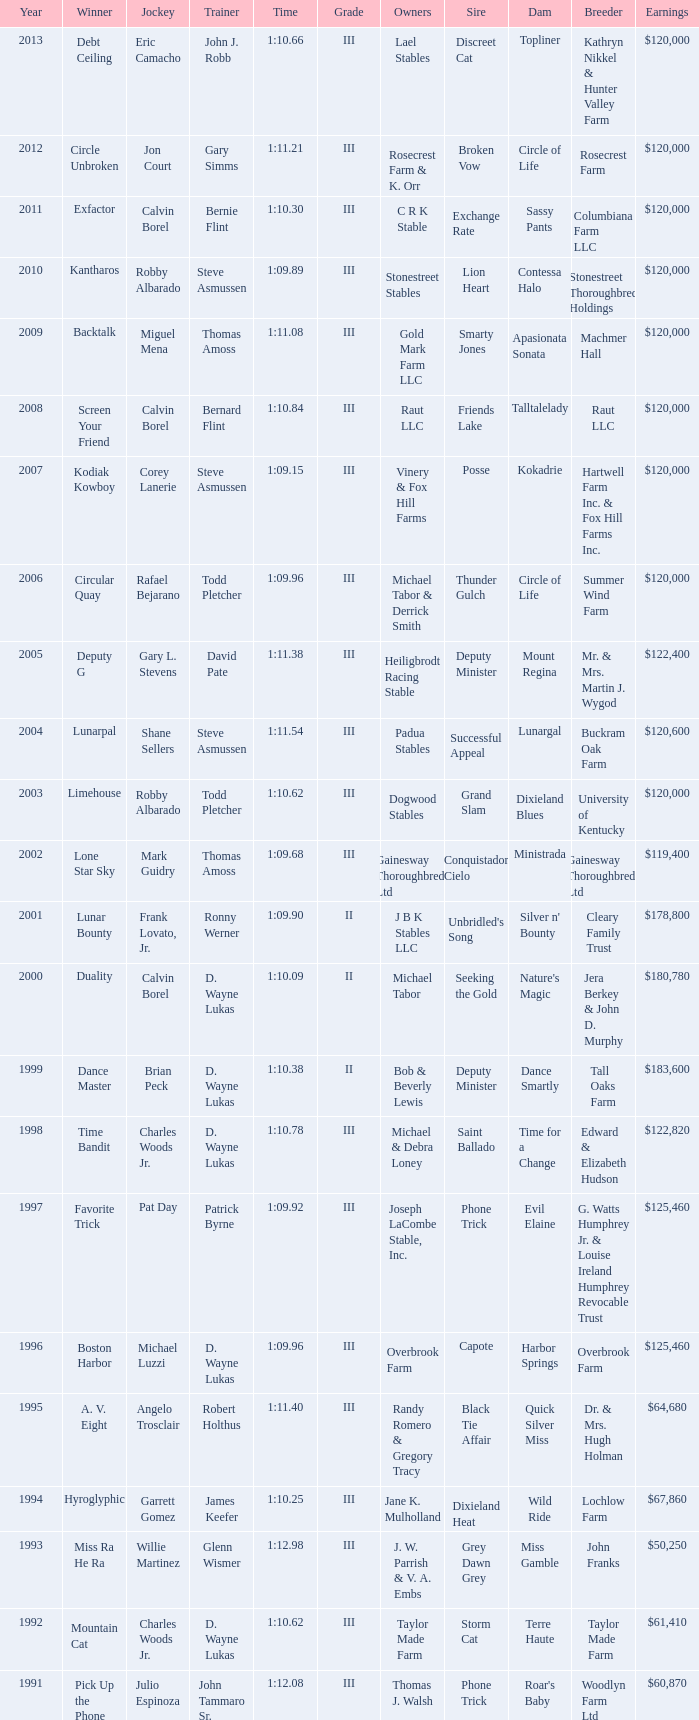What was the time for Screen Your Friend? 1:10.84. 